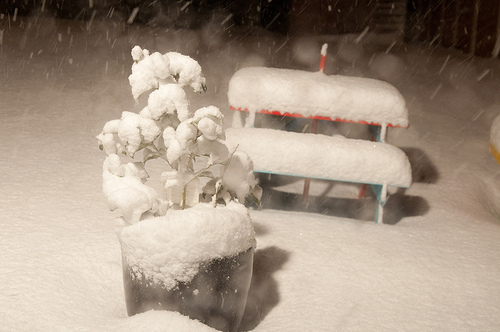<image>
Is there a snow to the left of the table? No. The snow is not to the left of the table. From this viewpoint, they have a different horizontal relationship. Is there a snow above the plant? No. The snow is not positioned above the plant. The vertical arrangement shows a different relationship. 